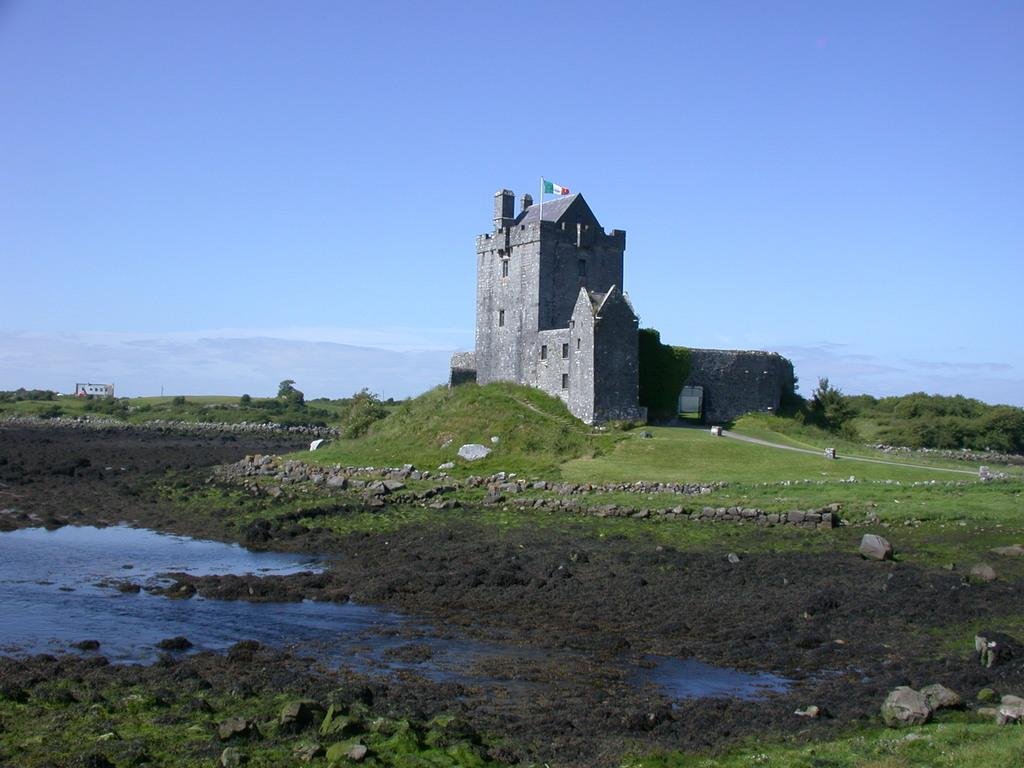What is the main subject in the center of the image? There is a building in the center of the image. What features can be observed on the building? The building has windows and a roof. Is there any symbol or emblem on the building? Yes, there is a flag on the building. What can be seen in the background of the image? There is a group of trees, at least one other building, and water visible in the background. How would you describe the weather in the image? The sky is cloudy in the image. How many roses are growing on the building in the image? There are no roses visible on the building in the image. What is the value of the quarter seen on the roof of the building? There is no quarter present on the roof of the building in the image. 